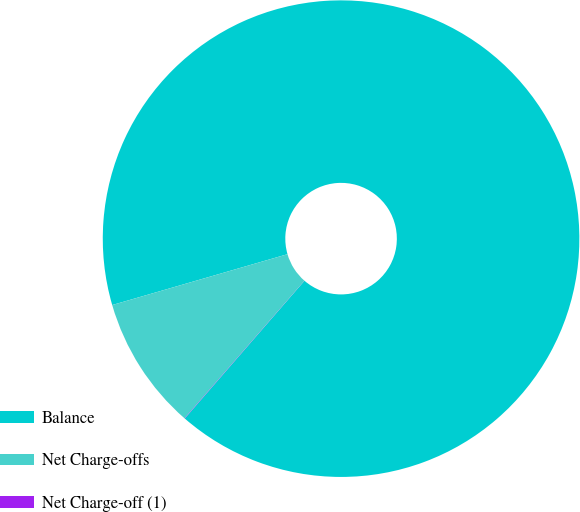Convert chart to OTSL. <chart><loc_0><loc_0><loc_500><loc_500><pie_chart><fcel>Balance<fcel>Net Charge-offs<fcel>Net Charge-off (1)<nl><fcel>90.88%<fcel>9.1%<fcel>0.02%<nl></chart> 